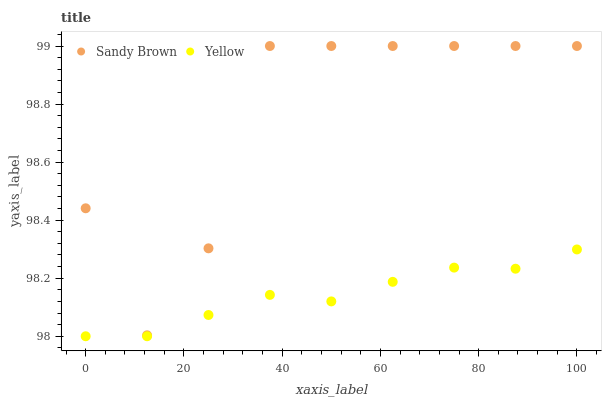Does Yellow have the minimum area under the curve?
Answer yes or no. Yes. Does Sandy Brown have the maximum area under the curve?
Answer yes or no. Yes. Does Yellow have the maximum area under the curve?
Answer yes or no. No. Is Yellow the smoothest?
Answer yes or no. Yes. Is Sandy Brown the roughest?
Answer yes or no. Yes. Is Yellow the roughest?
Answer yes or no. No. Does Yellow have the lowest value?
Answer yes or no. Yes. Does Sandy Brown have the highest value?
Answer yes or no. Yes. Does Yellow have the highest value?
Answer yes or no. No. Is Yellow less than Sandy Brown?
Answer yes or no. Yes. Is Sandy Brown greater than Yellow?
Answer yes or no. Yes. Does Yellow intersect Sandy Brown?
Answer yes or no. No. 